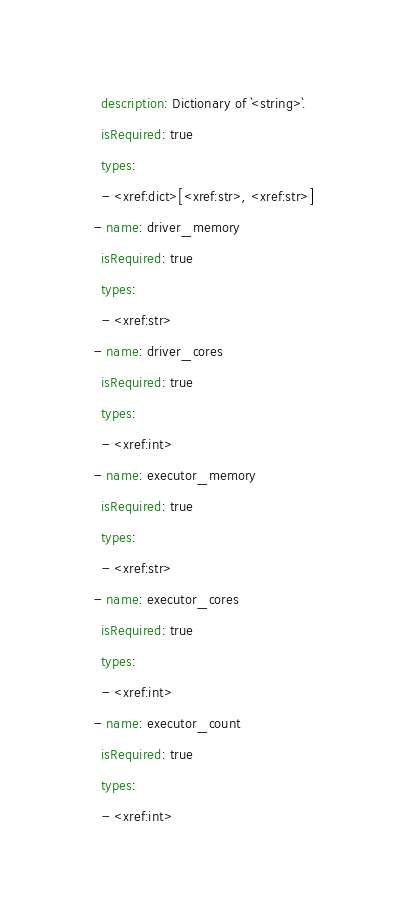Convert code to text. <code><loc_0><loc_0><loc_500><loc_500><_YAML_>    description: Dictionary of `<string>`.
    isRequired: true
    types:
    - <xref:dict>[<xref:str>, <xref:str>]
  - name: driver_memory
    isRequired: true
    types:
    - <xref:str>
  - name: driver_cores
    isRequired: true
    types:
    - <xref:int>
  - name: executor_memory
    isRequired: true
    types:
    - <xref:str>
  - name: executor_cores
    isRequired: true
    types:
    - <xref:int>
  - name: executor_count
    isRequired: true
    types:
    - <xref:int>
</code> 